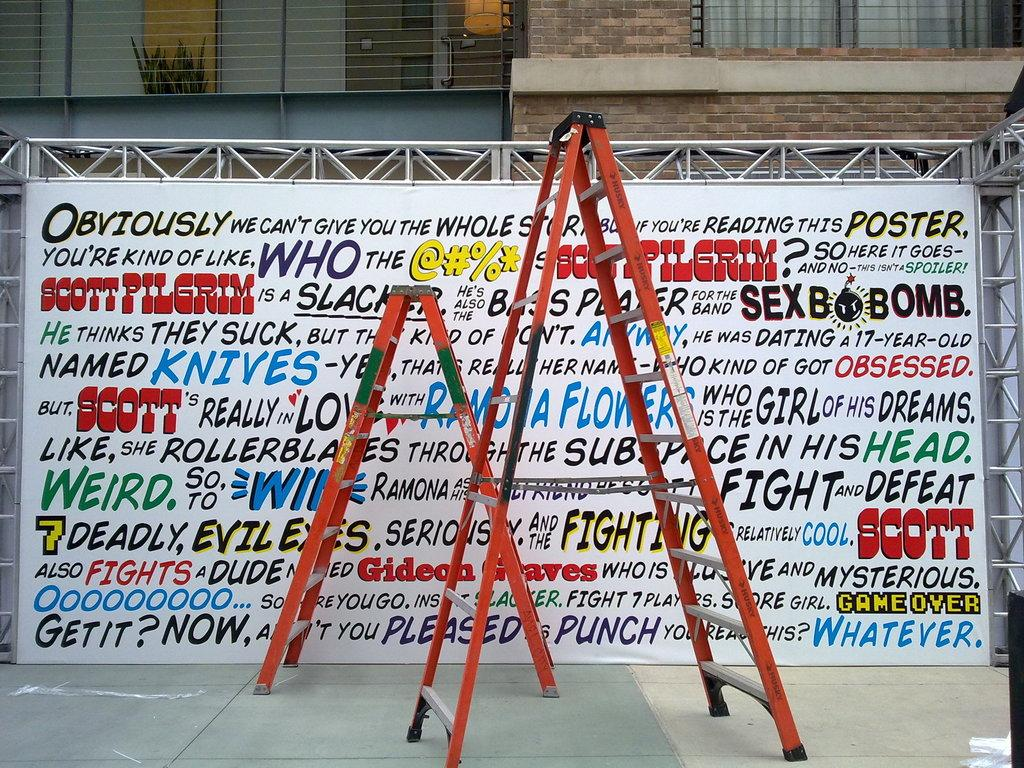<image>
Present a compact description of the photo's key features. Two ladders in front of a banner with lots of writing; the first word is obviously. 